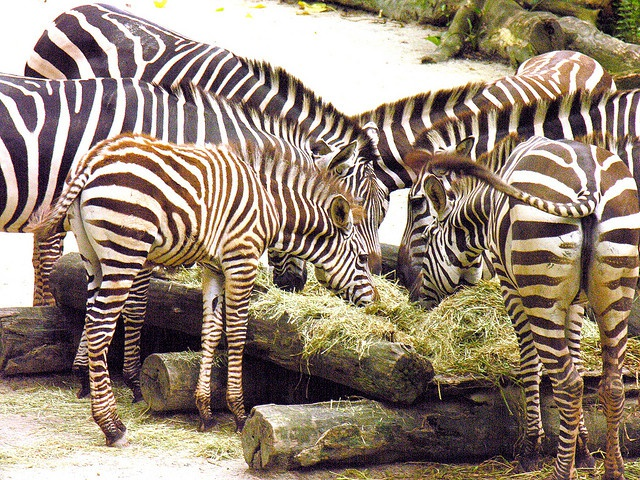Describe the objects in this image and their specific colors. I can see zebra in white, black, maroon, and olive tones, zebra in white, black, olive, and tan tones, zebra in white, gray, black, and brown tones, zebra in white, black, gray, and purple tones, and zebra in white, black, gray, and olive tones in this image. 